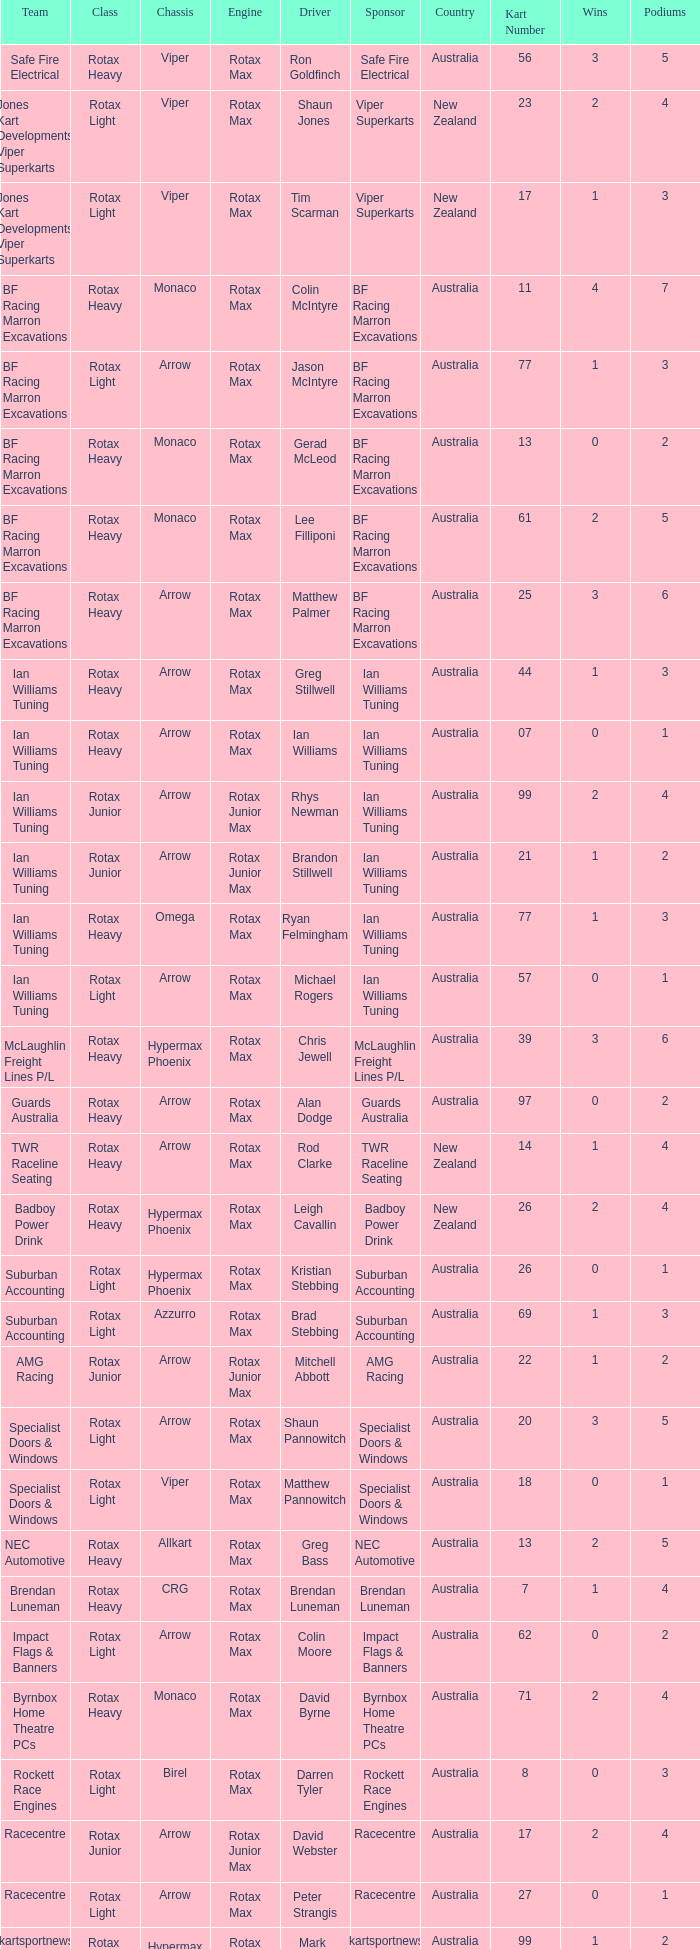What is the name of the team whose class is Rotax Light? Jones Kart Developments Viper Superkarts, Jones Kart Developments Viper Superkarts, BF Racing Marron Excavations, Ian Williams Tuning, Suburban Accounting, Suburban Accounting, Specialist Doors & Windows, Specialist Doors & Windows, Impact Flags & Banners, Rockett Race Engines, Racecentre, Doug Savage. 